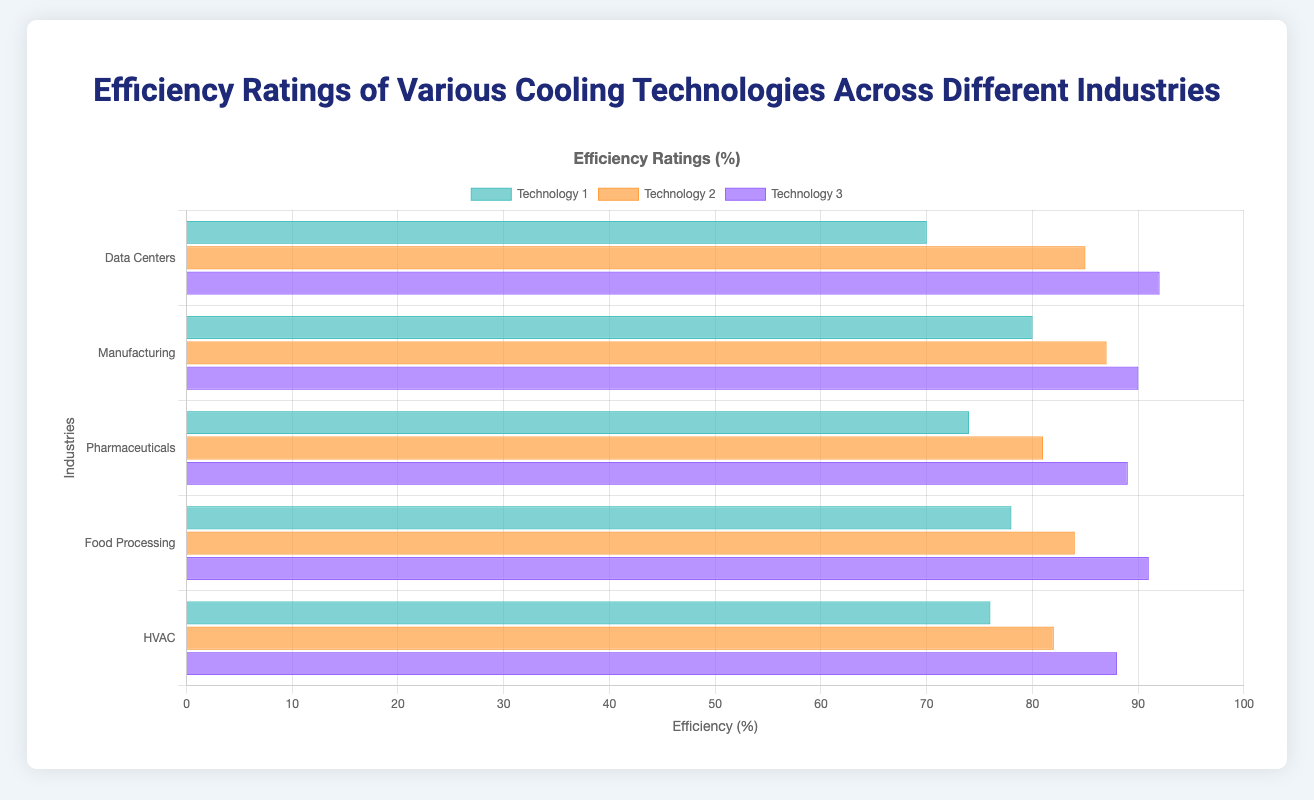Which cooling technology has the highest efficiency in Data Centers? The grouped bar chart for the 'Data Centers' industry shows three bars. The tallest bar in the Data Centers group represents 'Direct Liquid Cooling' with an efficiency of 92%.
Answer: Direct Liquid Cooling Compare the efficiency of the top technology in Pharmaceuticals and Food Processing. In the 'Pharmaceuticals' industry group, the tallest bar is for 'Cryogenic Cooling' with an efficiency of 89%. In the 'Food Processing' industry group, the tallest bar is for 'Liquid Nitrogen Freezing' with an efficiency of 91%. Since 91% is higher than 89%, 'Liquid Nitrogen Freezing' in the Food Processing industry has a higher efficiency.
Answer: Food Processing What is the total efficiency of all technologies in the Manufacturing industry? Find the three efficiencies in the Manufacturing industry group: 'Evaporative Cooling' is 80%, 'Hybrid Cooling' is 87%, and 'Thermal Storage' is 90%. Adding these gives 80 + 87 + 90 = 257%.
Answer: 257% Which technology has the lowest efficiency among all shown technologies? Inspect all the bars in the chart to find the shortest one. 'Air-Cooled Chillers' in the Data Centers industry has the lowest efficiency at 70%.
Answer: Air-Cooled Chillers Compare the efficiency of Water-Cooled Chillers and Variable Refrigerant Flow (VRF). The grouped bar for 'Water-Cooled Chillers' in Data Centers shows an efficiency of 85%. The grouped bar for 'Variable Refrigerant Flow' in HVAC shows an efficiency of 82%. Comparing these values, Water-Cooled Chillers (85%) is more efficient than Variable Refrigerant Flow (82%).
Answer: Water-Cooled Chillers Determine the average efficiency of technologies in the HVAC industry. Find the three efficiencies in HVAC: 'Geothermal Heat Pumps' is 76%, 'Variable Refrigerant Flow' is 82%, and 'Ductless Mini-Split Systems' is 88%. Average = (76 + 82 + 88) / 3 = 246 / 3 = 82%.
Answer: 82% Between Data Centers and Manufacturing, which industry has a higher average efficiency for its technologies? Calculate the average efficiency for Data Centers: (70 + 85 + 92) / 3 = 247 / 3 ≈ 82.33%. Calculate the average efficiency for Manufacturing: (80 + 87 + 90) / 3 = 257 / 3 ≈ 85.67%. Manufacturing has a higher average efficiency.
Answer: Manufacturing Which industry uses Cryogenic Cooling and what is its efficiency? Examine the industries in the chart to find where Cryogenic Cooling is listed. Cryogenic Cooling is used in the 'Pharmaceuticals' industry, with an efficiency of 89%.
Answer: Pharmaceuticals 